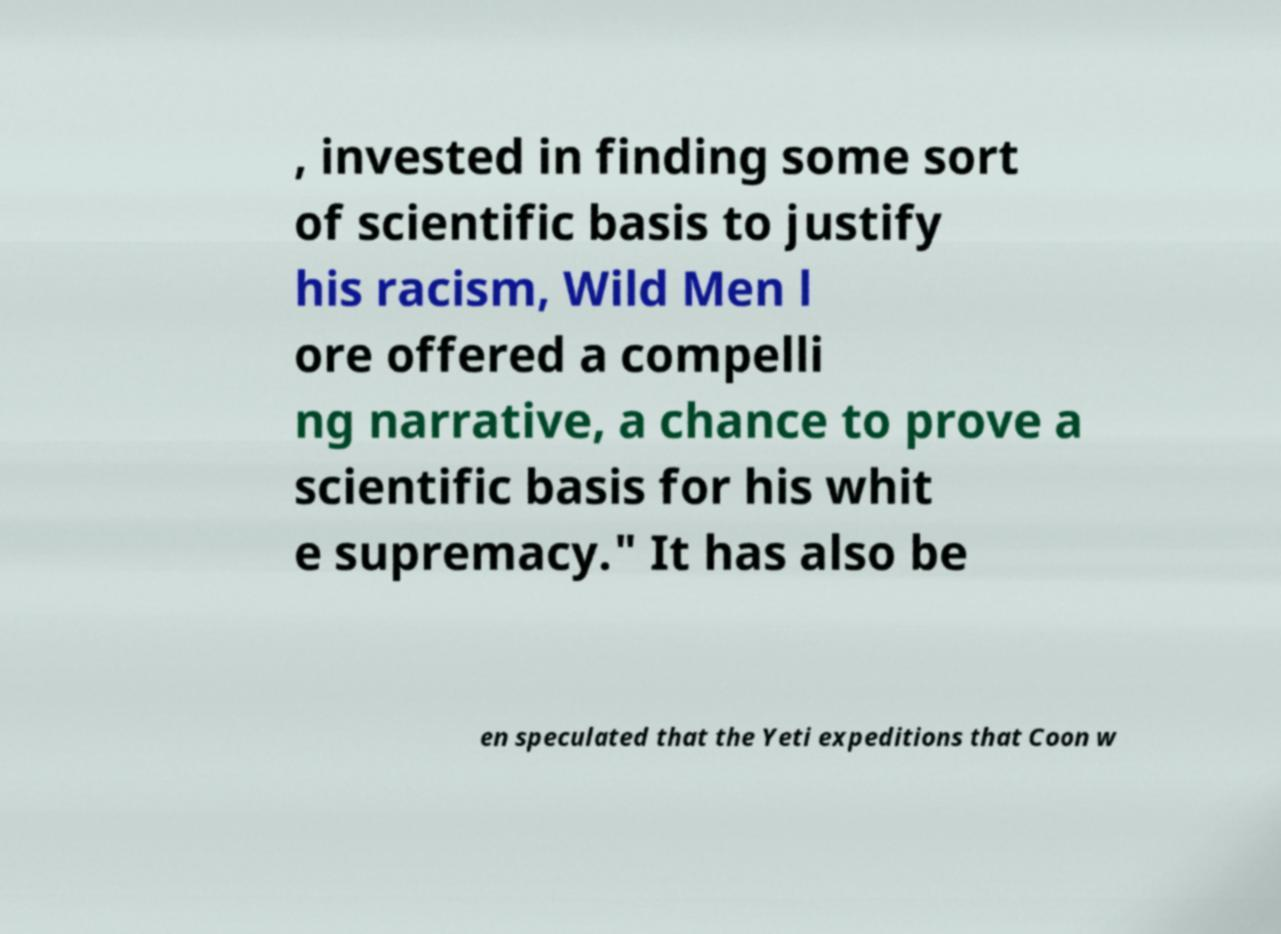I need the written content from this picture converted into text. Can you do that? , invested in finding some sort of scientific basis to justify his racism, Wild Men l ore offered a compelli ng narrative, a chance to prove a scientific basis for his whit e supremacy." It has also be en speculated that the Yeti expeditions that Coon w 